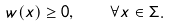Convert formula to latex. <formula><loc_0><loc_0><loc_500><loc_500>w ( x ) \geq 0 , \quad \forall x \in \Sigma .</formula> 